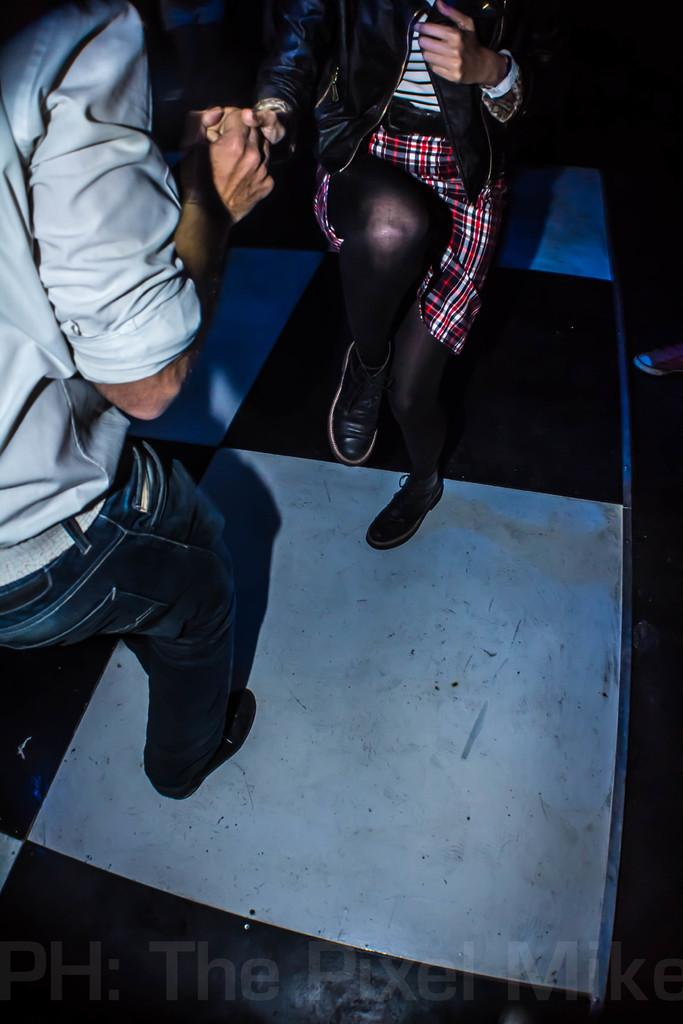Who are the people in the image? There is a man and a woman in the image. What are the man and woman doing in the image? Both the man and woman are standing on the floor. Is there any text present in the image? Yes, there is text at the bottom of the image. What type of tank can be seen in the image? There is no tank present in the image. What color is the cap worn by the man in the image? There is no cap visible on the man in the image. 